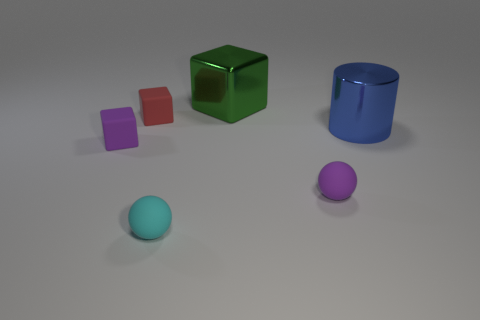There is a rubber ball to the right of the big green metallic cube; does it have the same color as the block that is in front of the large blue object?
Your response must be concise. Yes. There is a cube right of the tiny thing that is behind the cylinder; what is it made of?
Offer a very short reply. Metal. What color is the other sphere that is the same size as the cyan matte ball?
Provide a succinct answer. Purple. There is a cyan thing; is it the same shape as the tiny rubber object behind the big blue metal cylinder?
Your answer should be very brief. No. There is a small purple rubber object to the right of the big green metallic thing that is behind the purple rubber ball; how many purple rubber balls are behind it?
Ensure brevity in your answer.  0. How big is the metal thing in front of the cube that is on the right side of the red cube?
Your response must be concise. Large. The cylinder that is made of the same material as the green block is what size?
Offer a terse response. Large. There is a thing that is to the right of the small cyan matte object and behind the big cylinder; what shape is it?
Offer a very short reply. Cube. Are there an equal number of small cyan rubber balls that are left of the shiny block and small brown cylinders?
Make the answer very short. No. What number of things are small green cylinders or tiny purple matte objects right of the metallic cube?
Offer a very short reply. 1. 